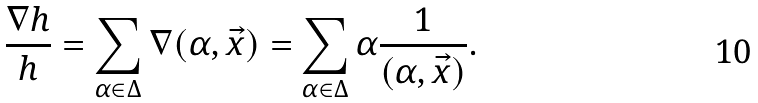Convert formula to latex. <formula><loc_0><loc_0><loc_500><loc_500>\frac { \nabla h } { h } = \sum _ { \alpha \in \Delta } \nabla ( \alpha , \vec { x } ) = \sum _ { \alpha \in \Delta } \alpha \frac { 1 } { ( \alpha , \vec { x } ) } .</formula> 